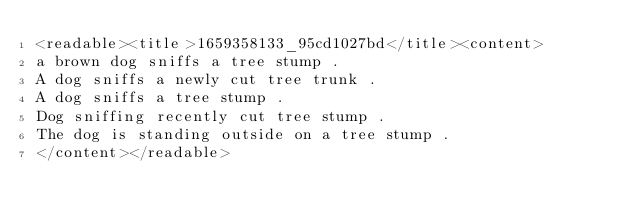<code> <loc_0><loc_0><loc_500><loc_500><_XML_><readable><title>1659358133_95cd1027bd</title><content>
a brown dog sniffs a tree stump .
A dog sniffs a newly cut tree trunk .
A dog sniffs a tree stump .
Dog sniffing recently cut tree stump .
The dog is standing outside on a tree stump .
</content></readable></code> 